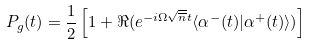<formula> <loc_0><loc_0><loc_500><loc_500>P _ { g } ( t ) = \frac { 1 } { 2 } \left [ 1 + \Re ( e ^ { - i \Omega \sqrt { \overline { n } } t } \langle { \alpha } ^ { - } ( t ) | { \alpha } ^ { + } ( t ) \rangle ) \right ]</formula> 